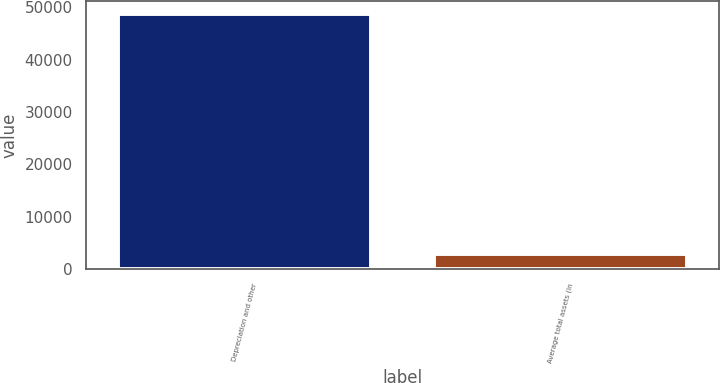Convert chart to OTSL. <chart><loc_0><loc_0><loc_500><loc_500><bar_chart><fcel>Depreciation and other<fcel>Average total assets (in<nl><fcel>48716<fcel>2858<nl></chart> 